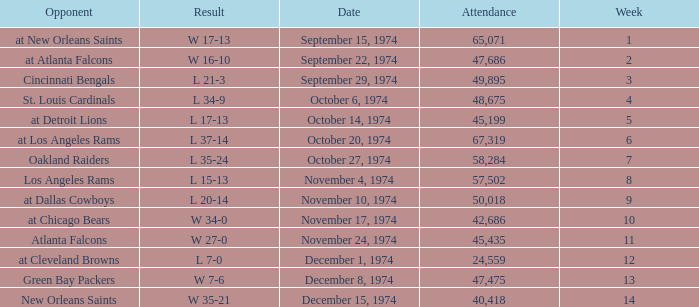What was the attendance when they played at Detroit Lions? 45199.0. 